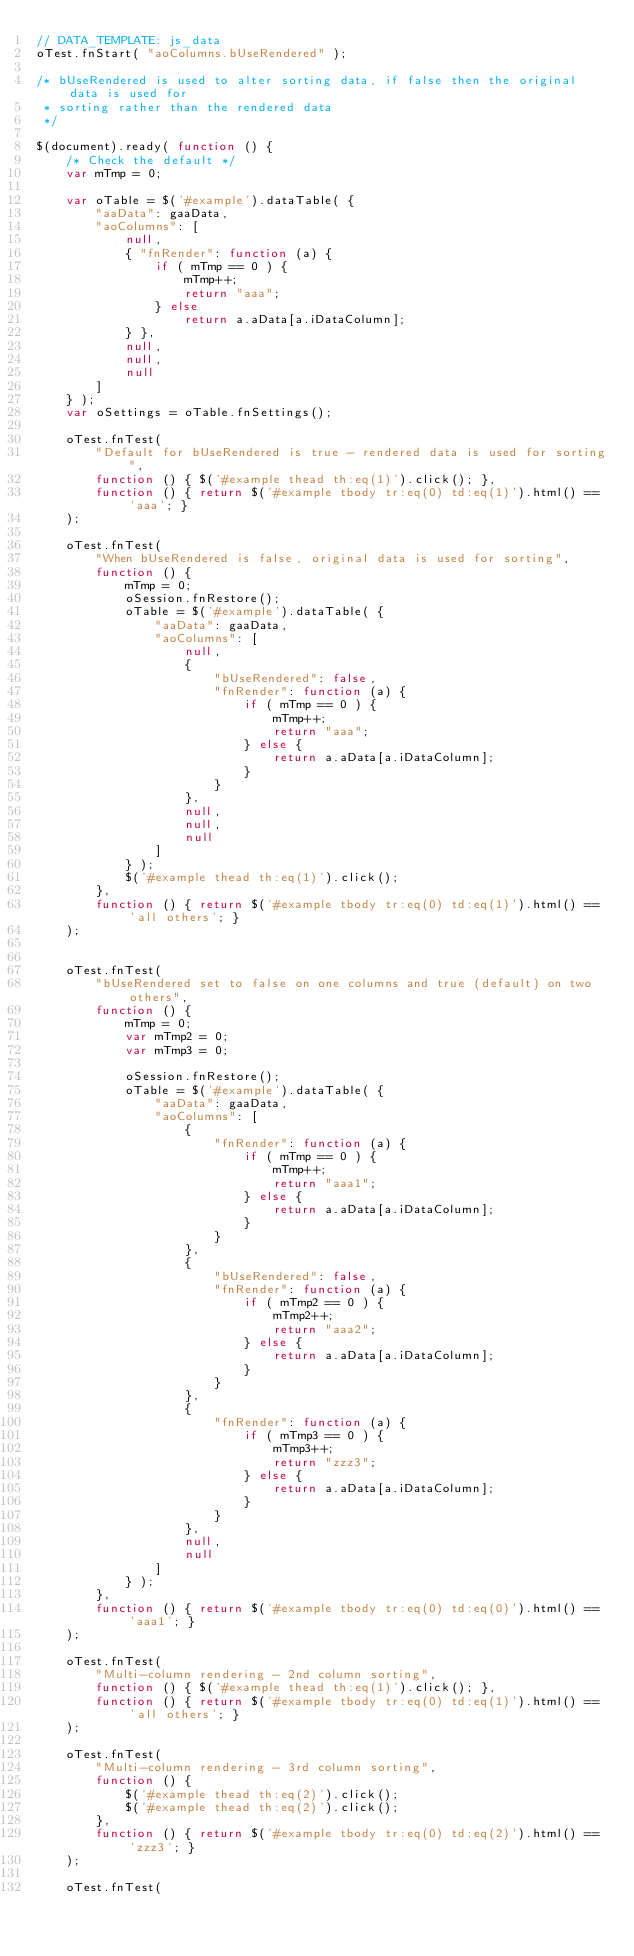<code> <loc_0><loc_0><loc_500><loc_500><_JavaScript_>// DATA_TEMPLATE: js_data
oTest.fnStart( "aoColumns.bUseRendered" );

/* bUseRendered is used to alter sorting data, if false then the original data is used for
 * sorting rather than the rendered data
 */

$(document).ready( function () {
	/* Check the default */
	var mTmp = 0;
	
	var oTable = $('#example').dataTable( {
		"aaData": gaaData,
		"aoColumns": [
			null,
			{ "fnRender": function (a) {
				if ( mTmp == 0 ) {
					mTmp++;
					return "aaa";
				} else
					return a.aData[a.iDataColumn];
			} },
			null,
			null,
			null
		]
	} );
	var oSettings = oTable.fnSettings();
	
	oTest.fnTest( 
		"Default for bUseRendered is true - rendered data is used for sorting",
		function () { $('#example thead th:eq(1)').click(); },
		function () { return $('#example tbody tr:eq(0) td:eq(1)').html() == 'aaa'; }
	);
	
	oTest.fnTest( 
		"When bUseRendered is false, original data is used for sorting",
		function () {
			mTmp = 0;
			oSession.fnRestore();
			oTable = $('#example').dataTable( {
				"aaData": gaaData,
				"aoColumns": [
					null,
					{ 
						"bUseRendered": false,
						"fnRender": function (a) {
							if ( mTmp == 0 ) {
								mTmp++;
								return "aaa";
							} else {
								return a.aData[a.iDataColumn];
							}
						}
					},
					null,
					null,
					null
				]
			} );
			$('#example thead th:eq(1)').click();
		},
		function () { return $('#example tbody tr:eq(0) td:eq(1)').html() == 'all others'; }
	);
	
	
	oTest.fnTest( 
		"bUseRendered set to false on one columns and true (default) on two others",
		function () {
			mTmp = 0;
			var mTmp2 = 0;
			var mTmp3 = 0;
			
			oSession.fnRestore();
			oTable = $('#example').dataTable( {
				"aaData": gaaData,
				"aoColumns": [
					{
						"fnRender": function (a) {
							if ( mTmp == 0 ) {
								mTmp++;
								return "aaa1";
							} else {
								return a.aData[a.iDataColumn];
							}
						}
					},
					{ 
						"bUseRendered": false,
						"fnRender": function (a) {
							if ( mTmp2 == 0 ) {
								mTmp2++;
								return "aaa2";
							} else {
								return a.aData[a.iDataColumn];
							}
						}
					},
					{
						"fnRender": function (a) {
							if ( mTmp3 == 0 ) {
								mTmp3++;
								return "zzz3";
							} else {
								return a.aData[a.iDataColumn];
							}
						}
					},
					null,
					null
				]
			} );
		},
		function () { return $('#example tbody tr:eq(0) td:eq(0)').html() == 'aaa1'; }
	);
	
	oTest.fnTest( 
		"Multi-column rendering - 2nd column sorting",
		function () { $('#example thead th:eq(1)').click(); },
		function () { return $('#example tbody tr:eq(0) td:eq(1)').html() == 'all others'; }
	);
	
	oTest.fnTest( 
		"Multi-column rendering - 3rd column sorting",
		function () {
			$('#example thead th:eq(2)').click();
			$('#example thead th:eq(2)').click();
		},
		function () { return $('#example tbody tr:eq(0) td:eq(2)').html() == 'zzz3'; }
	);
	
	oTest.fnTest( </code> 